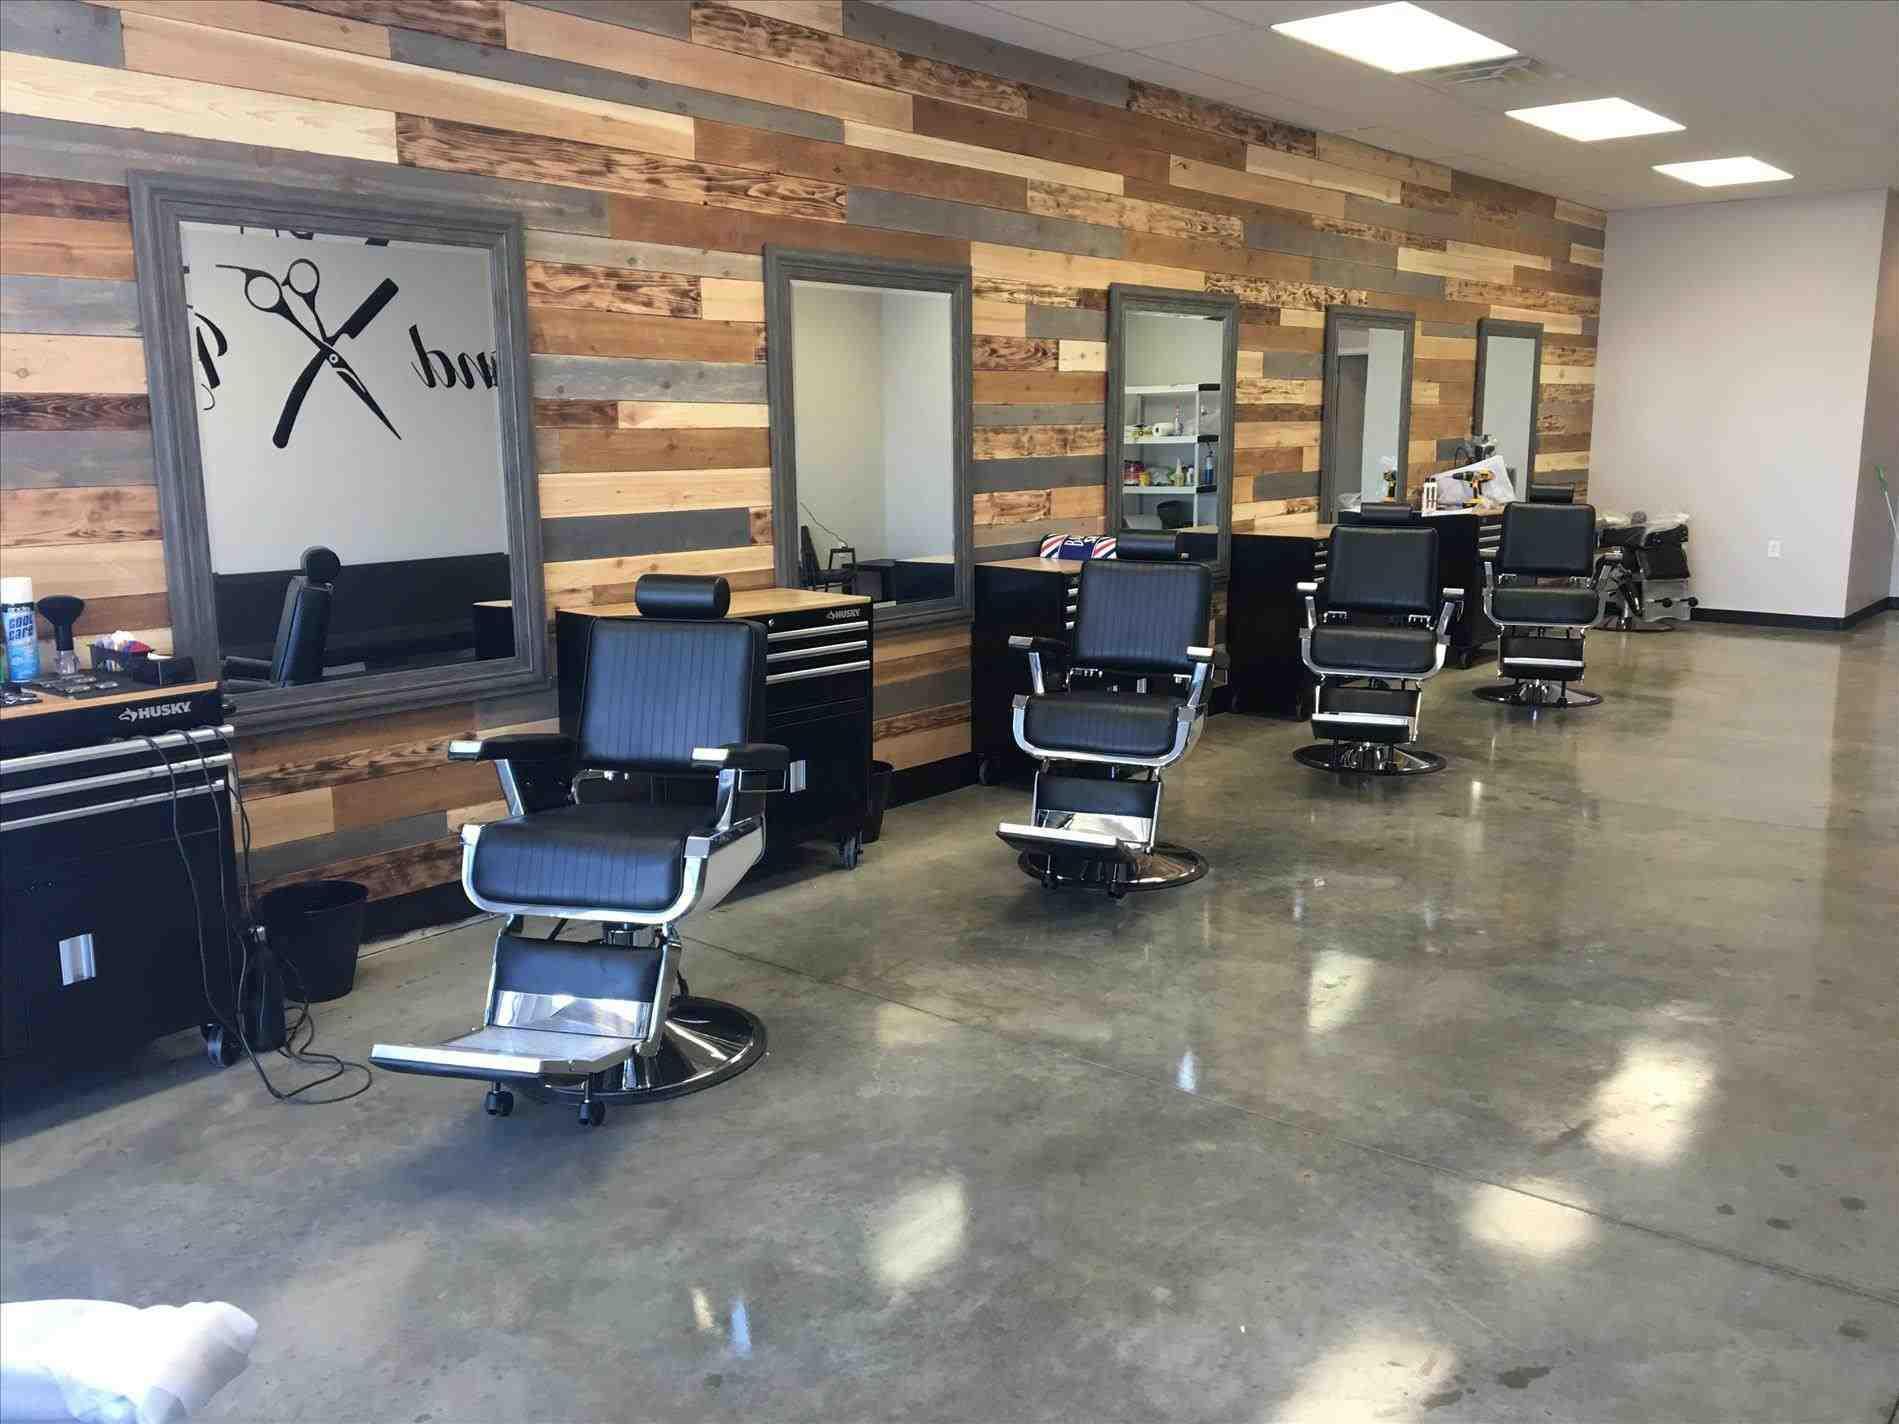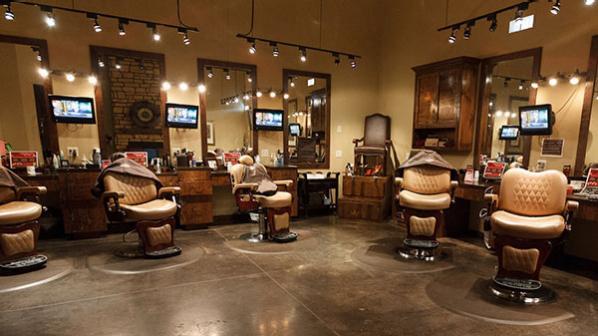The first image is the image on the left, the second image is the image on the right. Analyze the images presented: Is the assertion "the left image contains at least three chairs, the right image only contains one." valid? Answer yes or no. No. 